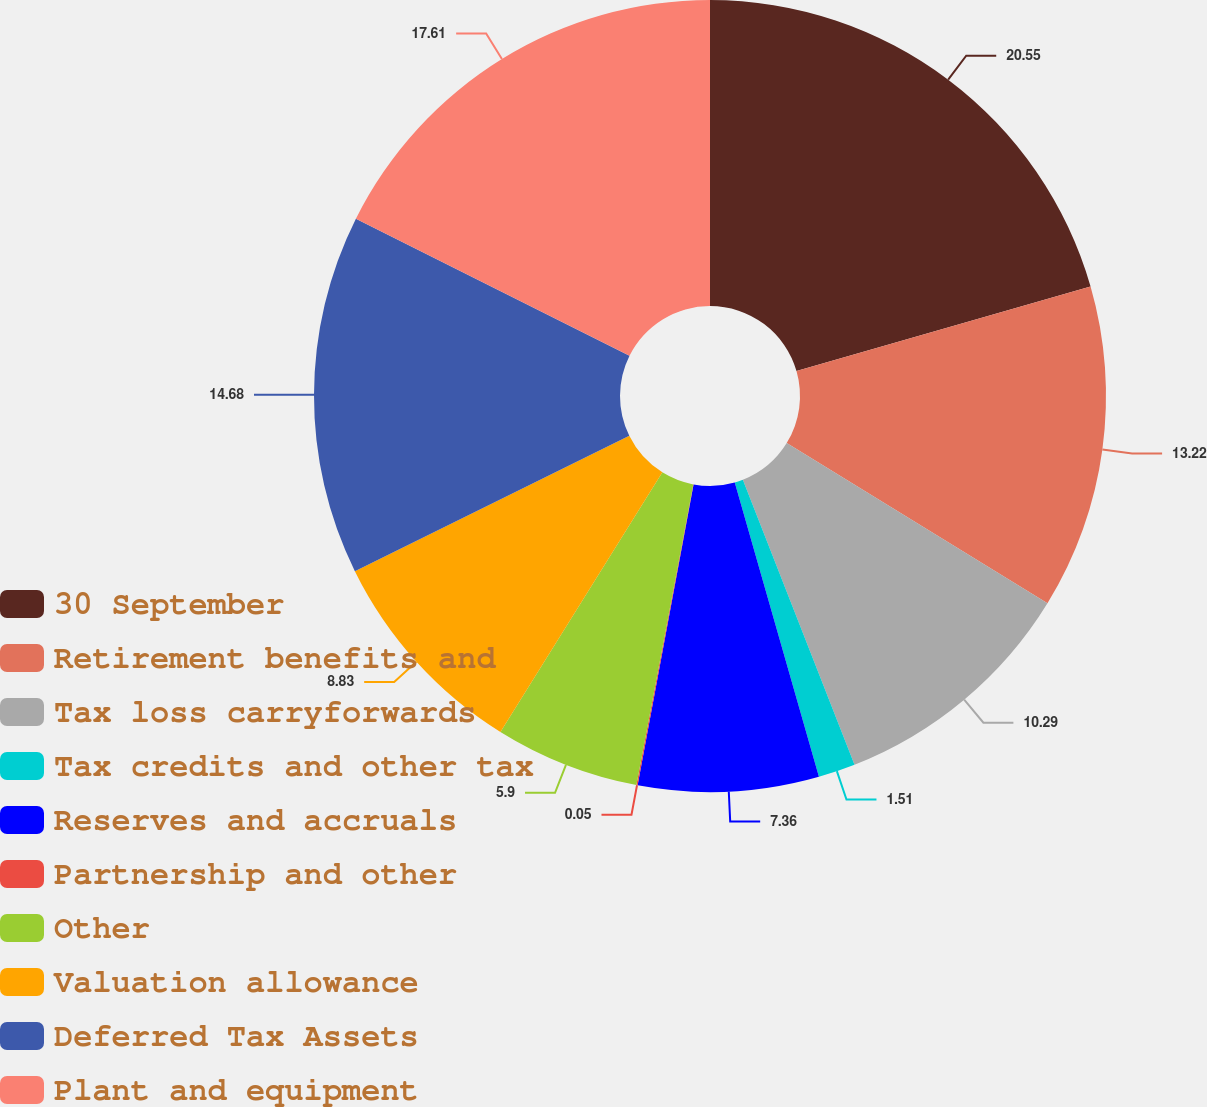<chart> <loc_0><loc_0><loc_500><loc_500><pie_chart><fcel>30 September<fcel>Retirement benefits and<fcel>Tax loss carryforwards<fcel>Tax credits and other tax<fcel>Reserves and accruals<fcel>Partnership and other<fcel>Other<fcel>Valuation allowance<fcel>Deferred Tax Assets<fcel>Plant and equipment<nl><fcel>20.54%<fcel>13.22%<fcel>10.29%<fcel>1.51%<fcel>7.36%<fcel>0.05%<fcel>5.9%<fcel>8.83%<fcel>14.68%<fcel>17.61%<nl></chart> 